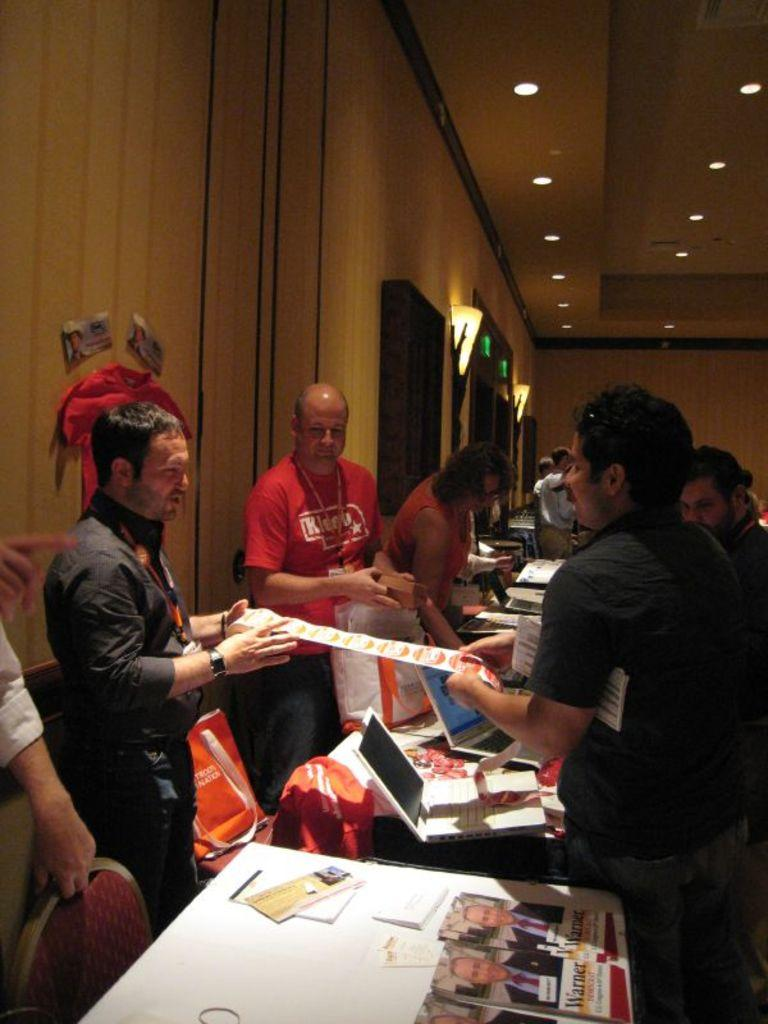What is the person in the image holding? The person is holding a camera. What is the person doing with the camera? The person is taking a picture. What is the subject of the picture being taken? The landscape is the subject of the picture. What can be seen in the background of the image? In the background of the image, there are mountains and trees. Is there a bike being ridden by someone in the image? No, there is no bike present in the image. Are the mountains in the background attacking the person taking the picture? No, the mountains are not attacking the person taking the picture; they are simply part of the landscape. 